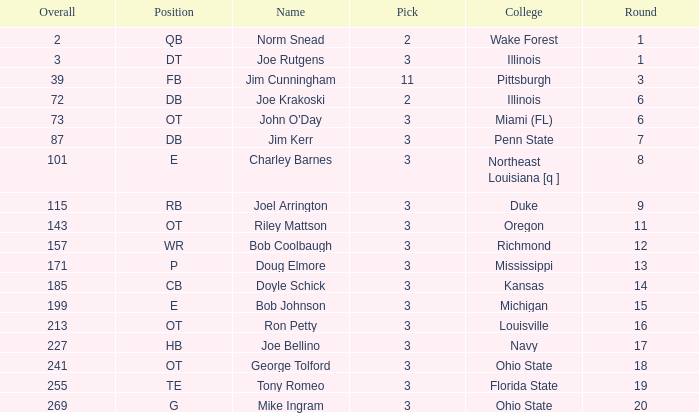How many rounds have john o'day as the name, and a pick less than 3? None. 